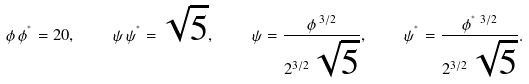Convert formula to latex. <formula><loc_0><loc_0><loc_500><loc_500>\phi \, \phi ^ { ^ { * } } = 2 0 , \quad \psi \, \psi ^ { ^ { * } } = \sqrt { 5 } , \quad \psi = \frac { \phi \, ^ { 3 / 2 } } { 2 ^ { 3 / 2 } \, \sqrt { 5 } } , \quad \psi ^ { ^ { * } } = \frac { \phi ^ { ^ { * } } \, ^ { 3 / 2 } } { 2 ^ { 3 / 2 } \, \sqrt { 5 } } .</formula> 